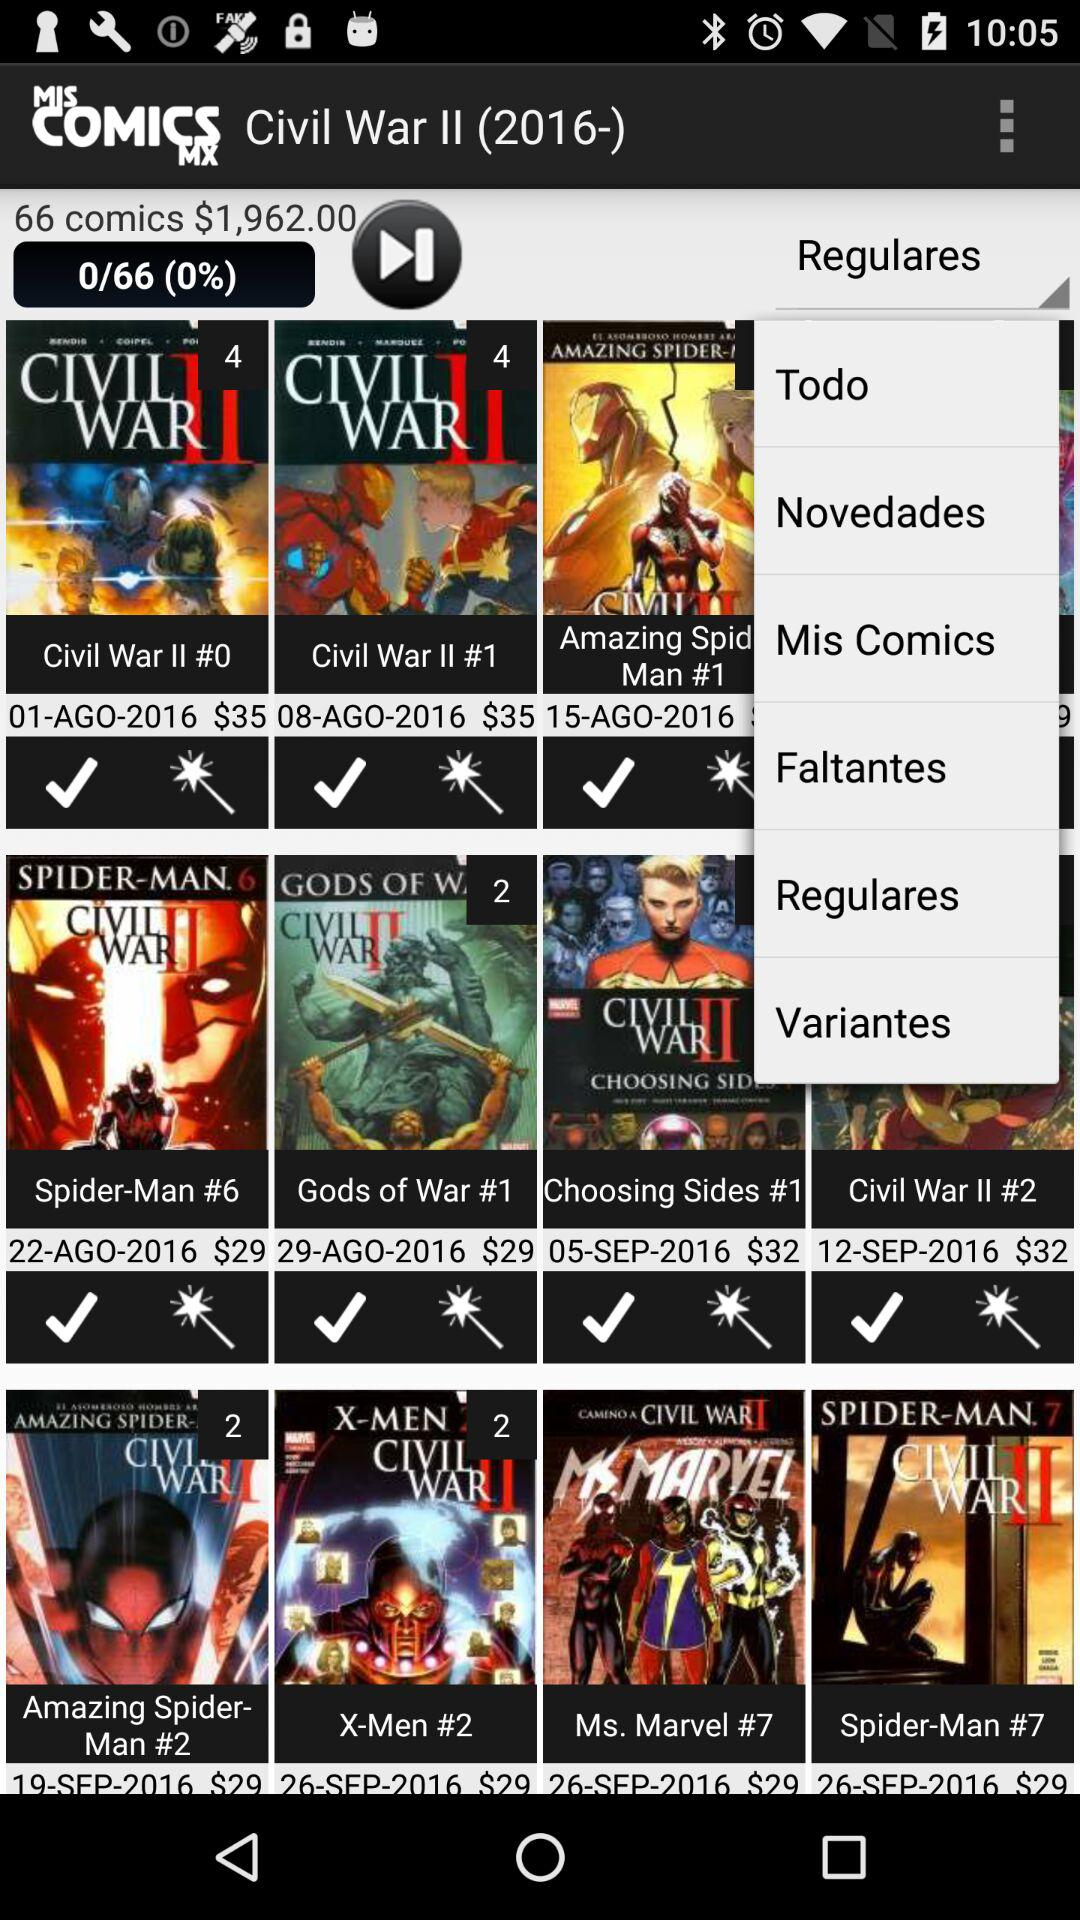How many comics in total are there? There are 66 comics. 